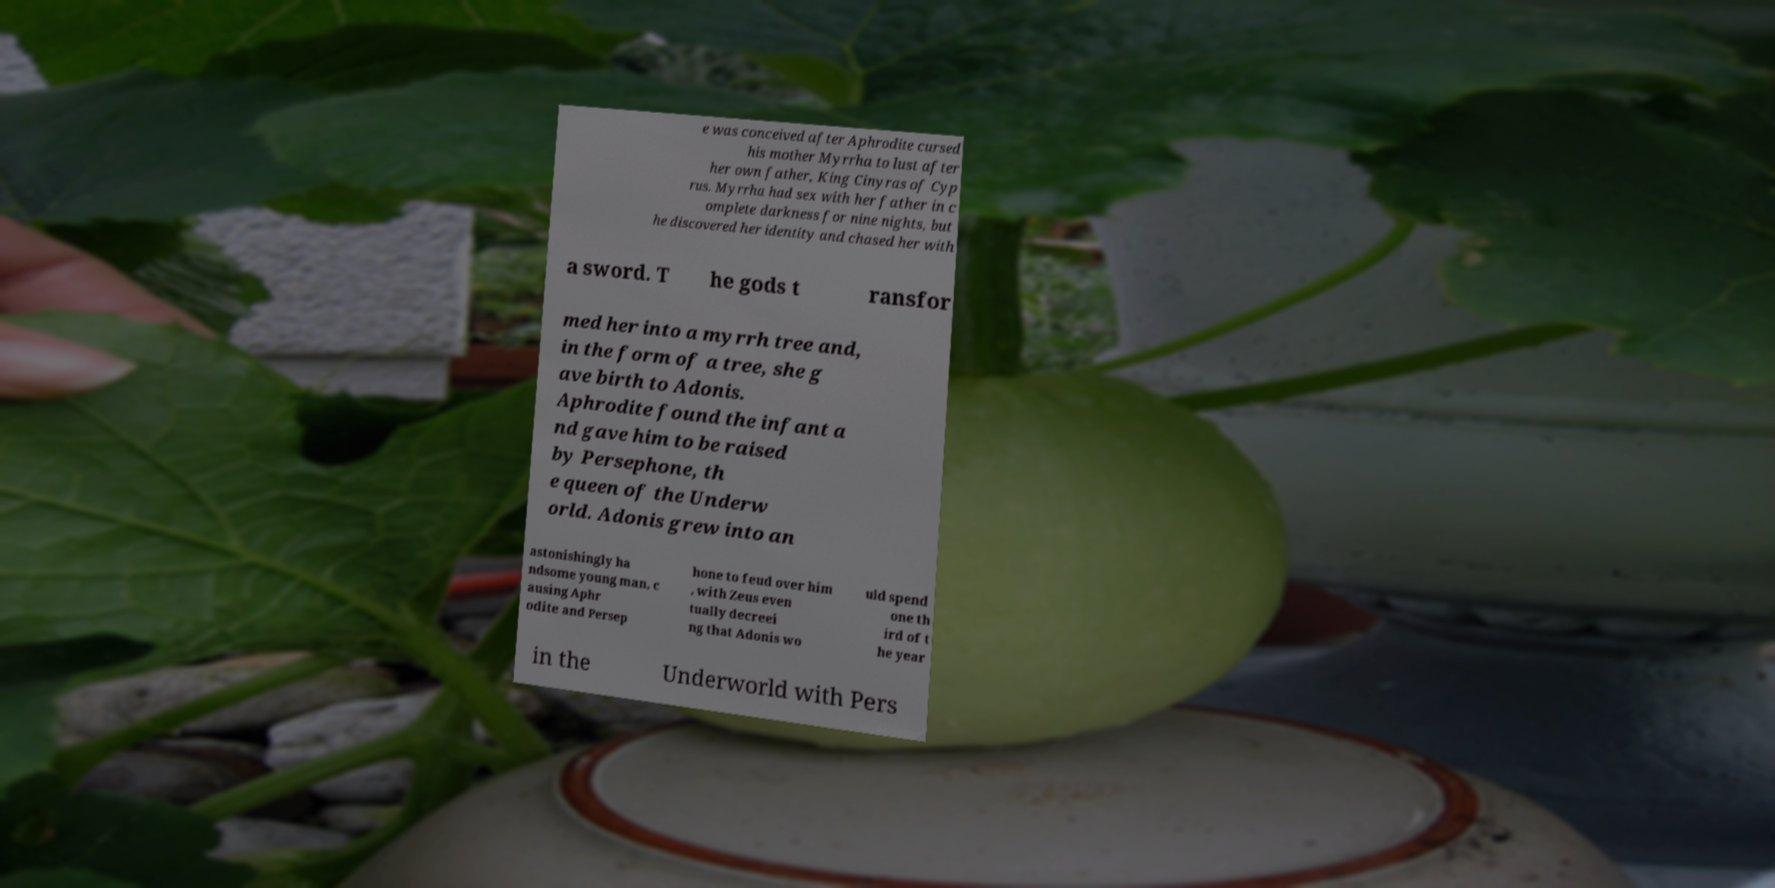Can you accurately transcribe the text from the provided image for me? e was conceived after Aphrodite cursed his mother Myrrha to lust after her own father, King Cinyras of Cyp rus. Myrrha had sex with her father in c omplete darkness for nine nights, but he discovered her identity and chased her with a sword. T he gods t ransfor med her into a myrrh tree and, in the form of a tree, she g ave birth to Adonis. Aphrodite found the infant a nd gave him to be raised by Persephone, th e queen of the Underw orld. Adonis grew into an astonishingly ha ndsome young man, c ausing Aphr odite and Persep hone to feud over him , with Zeus even tually decreei ng that Adonis wo uld spend one th ird of t he year in the Underworld with Pers 